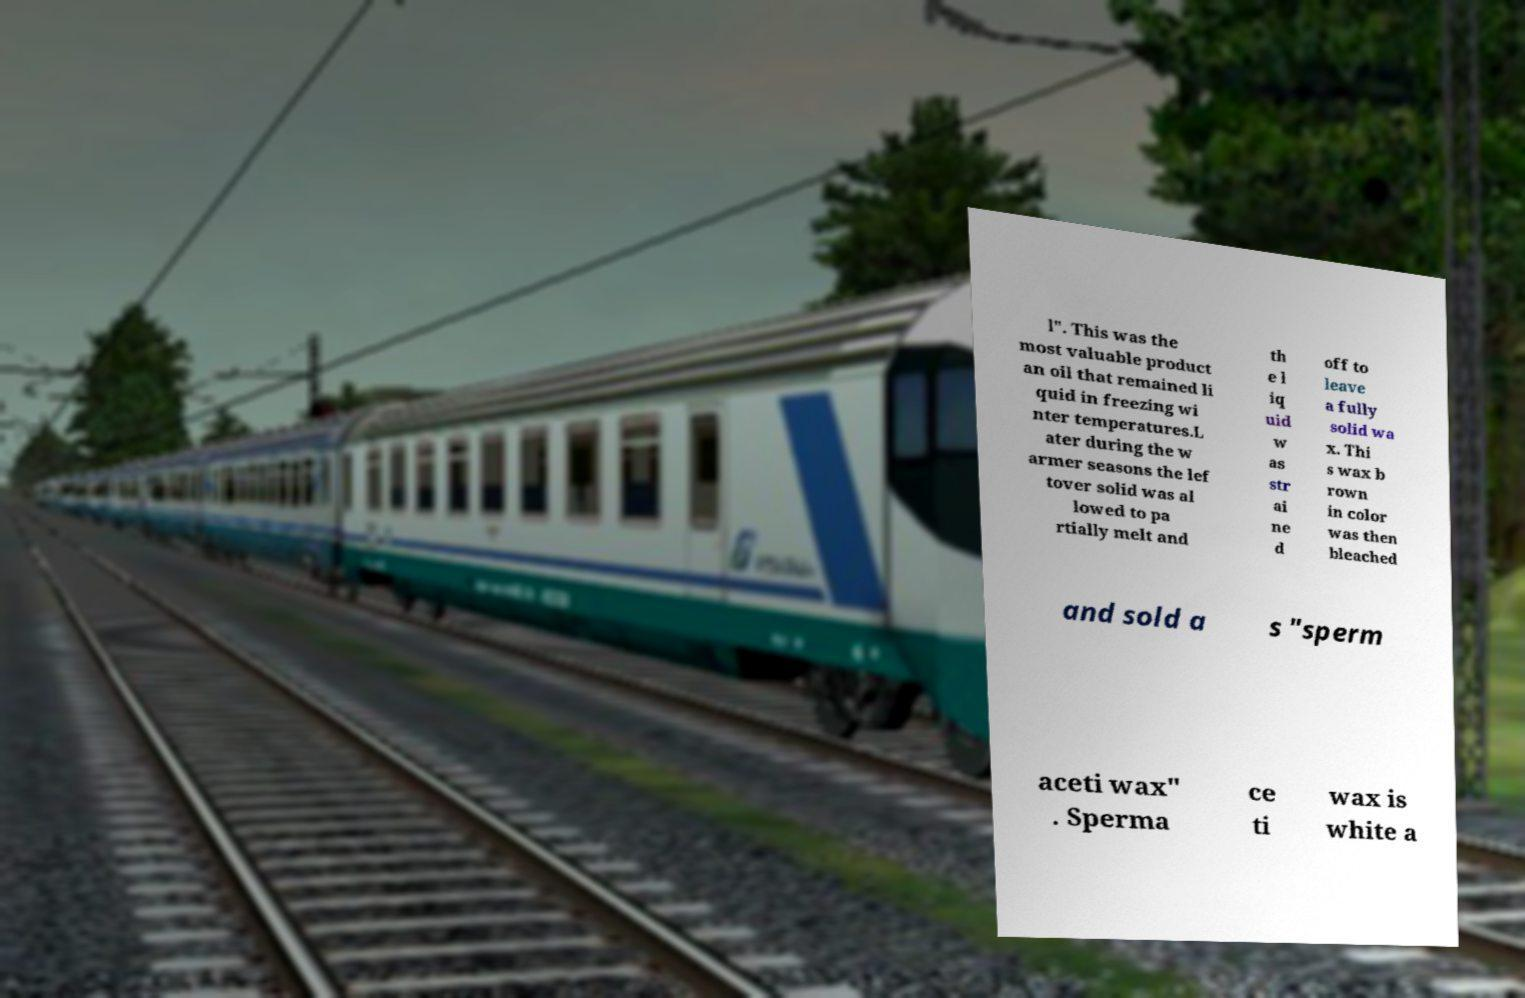For documentation purposes, I need the text within this image transcribed. Could you provide that? l". This was the most valuable product an oil that remained li quid in freezing wi nter temperatures.L ater during the w armer seasons the lef tover solid was al lowed to pa rtially melt and th e l iq uid w as str ai ne d off to leave a fully solid wa x. Thi s wax b rown in color was then bleached and sold a s "sperm aceti wax" . Sperma ce ti wax is white a 